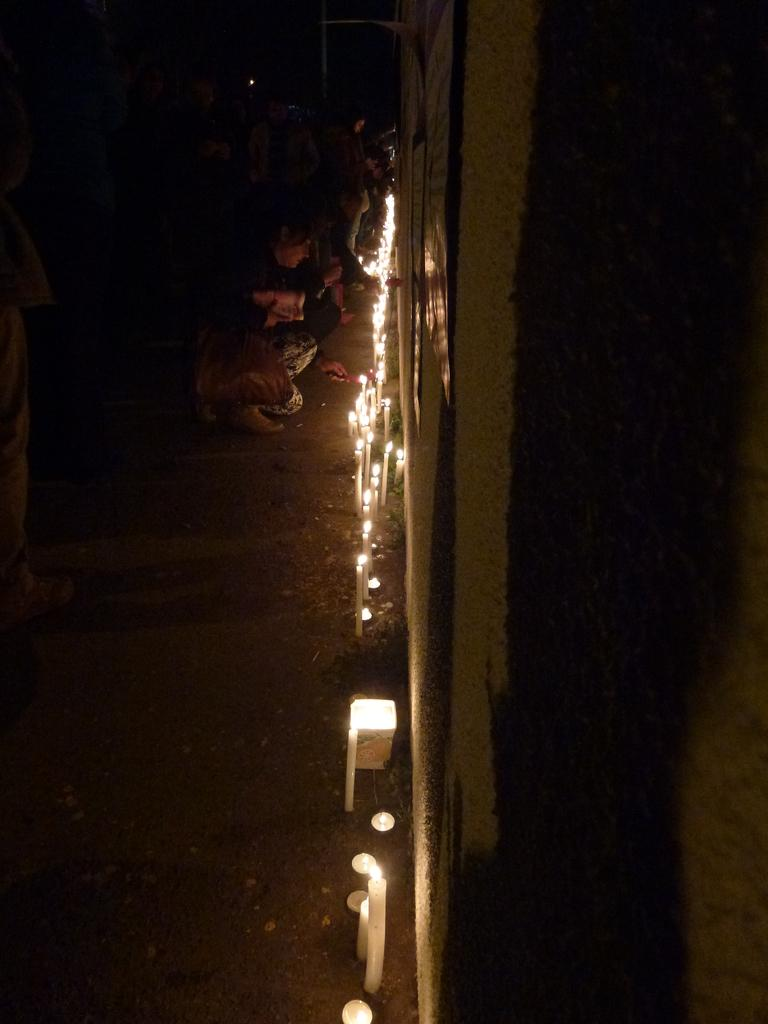Who or what is present in the image? There are people in the image. What is the purpose of the candles in the image? The candles are likely used for lighting or decoration. Can you describe any other objects in the image besides the candles? Yes, there are other objects in the image, but their specific details are not mentioned in the provided facts. What can be seen at the bottom of the image? The ground is visible at the bottom of the image. What is the appearance of the right side of the image? There appears to be a wall on the right side of the image. Are there any masks or collars visible on the people in the image? There is no mention of masks or collars in the provided facts, so we cannot determine if they are present in the image. What type of toys can be seen on the wall in the image? There is no mention of toys in the provided facts, so we cannot determine if they are present in the image. 